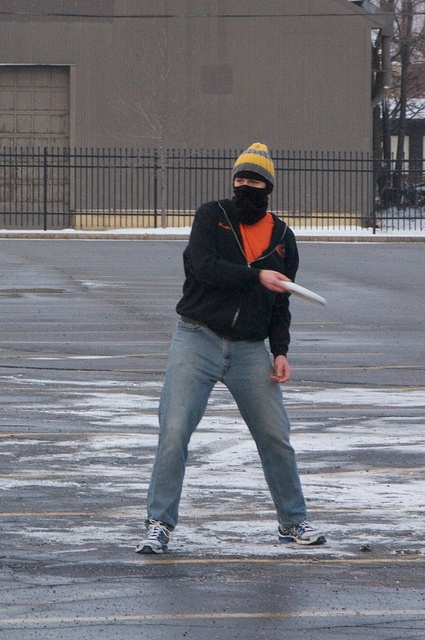Describe the objects in this image and their specific colors. I can see people in gray, black, and blue tones and frisbee in gray, darkgray, and lightgray tones in this image. 